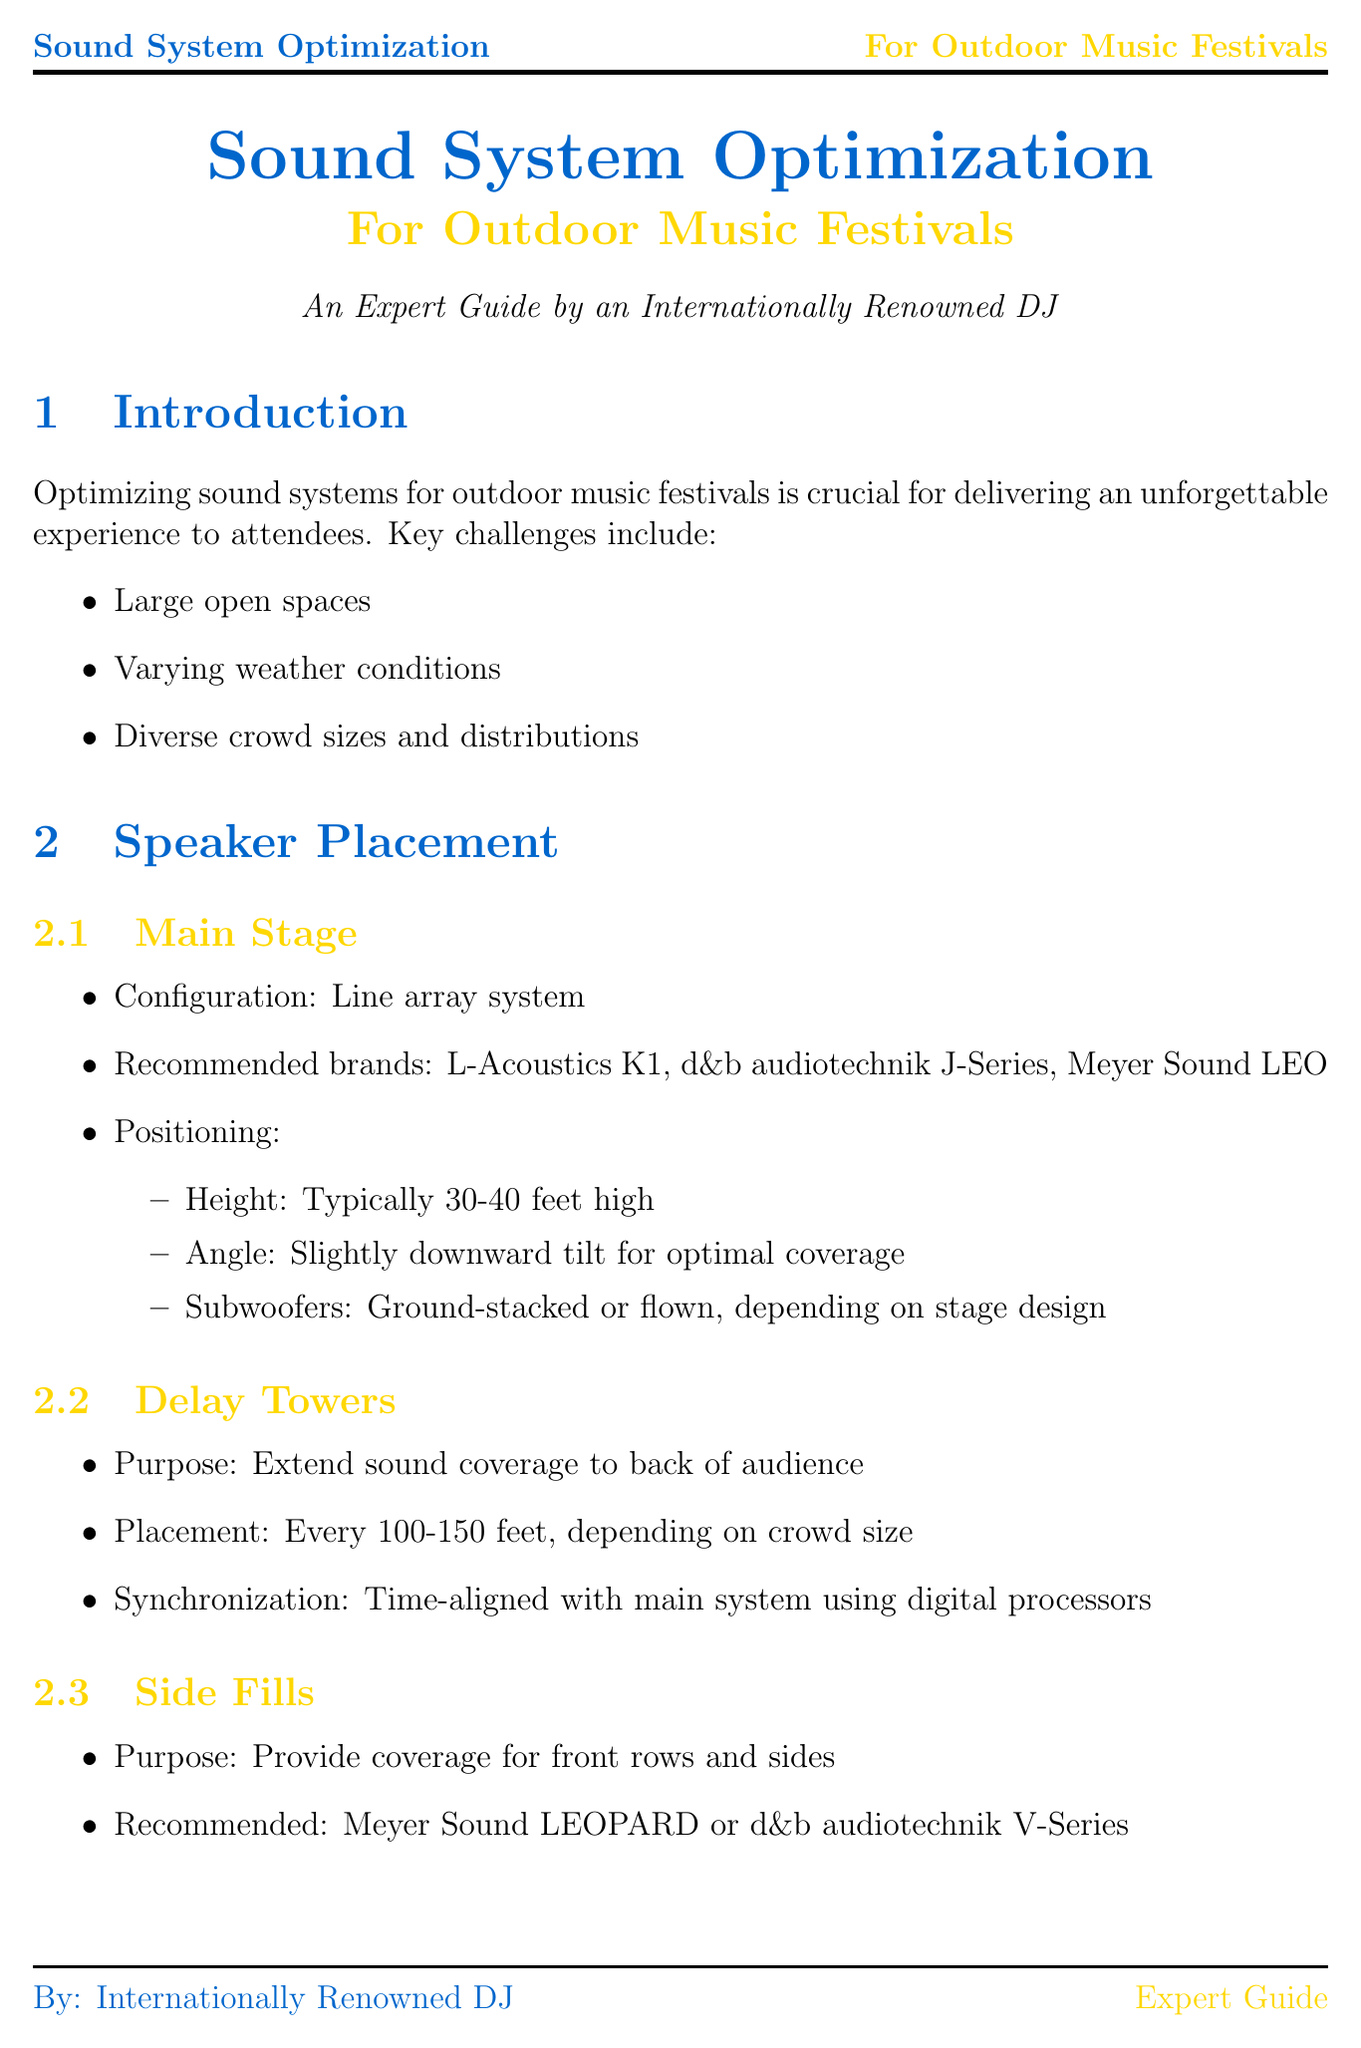What is the configuration used for the main stage? The main stage uses a line array system for its configuration.
Answer: line array system What should the height of the main stage speakers typically be? The document states that the height of main stage speakers should typically be 30-40 feet high.
Answer: 30-40 feet high What is the purpose of delay towers? Delay towers are used to extend sound coverage to the back of the audience.
Answer: Extend sound coverage to back of audience Name one recommended noise control method. The document lists several methods, and one of them is cardioid subwoofer arrays.
Answer: cardioid subwoofer arrays What type of monitor is preferred according to personal experience? The preferred in-ear monitors mentioned are Shure PSM 1000.
Answer: Shure PSM 1000 What is one emergency procedure established for wind? The document mentions that there should be a plan to lower line arrays if necessary when wind speeds are high.
Answer: Lower line arrays if necessary What are the recommended outdoor-rated cables used for? Outdoor-rated cables are used for ensuring durability and reliability in adverse weather conditions, as stated in the document.
Answer: Use outdoor-rated cables with waterproof connectors What type of technologies are mentioned for future trends? Beam-steering line arrays for more precise coverage is one of the future technologies mentioned.
Answer: Beam-steering line arrays What should the roof design be angled for? The roof design should be angled to prevent water pooling.
Answer: Prevent water pooling 